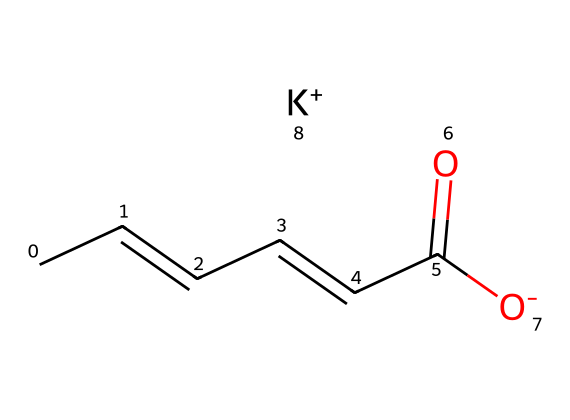What is the main functional group present in potassium sorbate? The main functional group in potassium sorbate is a carboxylate group (–COO–), which can be observed in the structure. This group is essential for its function as a preservative.
Answer: carboxylate How many carbon atoms are present in potassium sorbate? By examining the structure, there are six carbon atoms in total. This can be counted directly from the chemical structure shown by the SMILES representation.
Answer: six What type of chemical is potassium sorbate classified as? Potassium sorbate is classified as a preservative due to its ability to inhibit the growth of mold and yeasts in food and beverages.
Answer: preservative Which ion is associated with potassium sorbate? The potassium ion (K+) is associated with potassium sorbate, as indicated in the SMILES representation where "K+" is explicitly mentioned.
Answer: potassium What is the oxidation state of carbon in the carboxylate group of potassium sorbate? In the carboxylate group, the carbon involved has an oxidation state of +3, derived from its bonding to two oxygen atoms (one double-bonded and one single-bonded).
Answer: +3 What does the presence of a double bond in potassium sorbate imply about its reactivity? The presence of a double bond indicates that the compound may undergo additional types of reactions, such as addition reactions, which can alter its structure and effectiveness as a preservative.
Answer: additional reactions What is the charge of the chemical species in the potassium sorbate compound? The charge of the potassium sorbate species is -1, which comes from the carboxylate ion (–COO–), while the potassium provides a +1 charge overall, making the compound neutral.
Answer: -1 